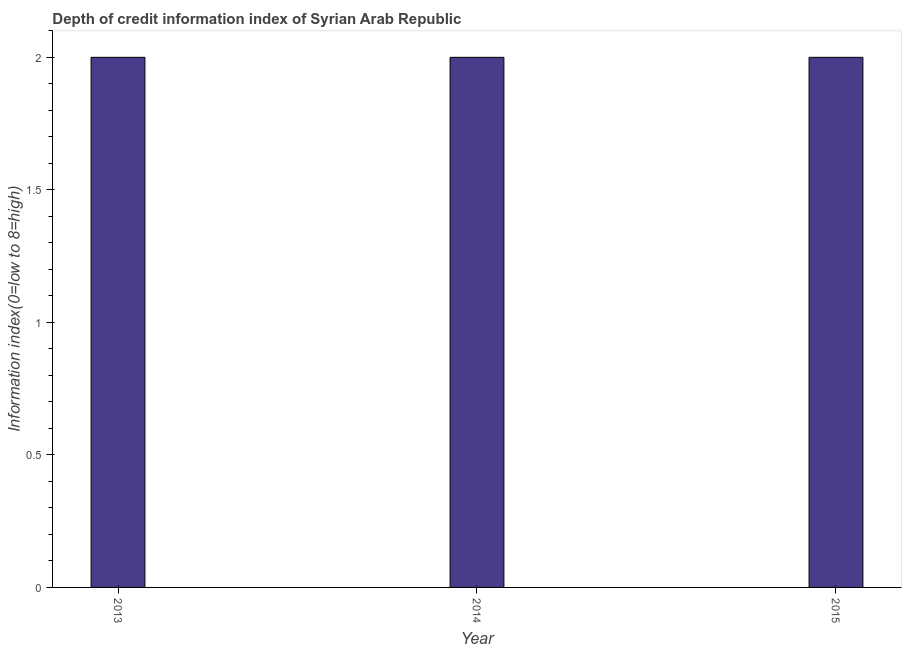Does the graph contain grids?
Your answer should be very brief. No. What is the title of the graph?
Your response must be concise. Depth of credit information index of Syrian Arab Republic. What is the label or title of the X-axis?
Offer a terse response. Year. What is the label or title of the Y-axis?
Ensure brevity in your answer.  Information index(0=low to 8=high). What is the depth of credit information index in 2013?
Provide a succinct answer. 2. In which year was the depth of credit information index minimum?
Your answer should be compact. 2013. What is the difference between the depth of credit information index in 2013 and 2014?
Give a very brief answer. 0. What is the average depth of credit information index per year?
Provide a short and direct response. 2. What is the median depth of credit information index?
Make the answer very short. 2. What is the difference between the highest and the lowest depth of credit information index?
Make the answer very short. 0. In how many years, is the depth of credit information index greater than the average depth of credit information index taken over all years?
Provide a succinct answer. 0. How many bars are there?
Ensure brevity in your answer.  3. What is the difference between two consecutive major ticks on the Y-axis?
Your response must be concise. 0.5. Are the values on the major ticks of Y-axis written in scientific E-notation?
Offer a very short reply. No. What is the Information index(0=low to 8=high) in 2015?
Your answer should be very brief. 2. What is the difference between the Information index(0=low to 8=high) in 2013 and 2014?
Keep it short and to the point. 0. What is the difference between the Information index(0=low to 8=high) in 2013 and 2015?
Your answer should be compact. 0. What is the difference between the Information index(0=low to 8=high) in 2014 and 2015?
Make the answer very short. 0. 